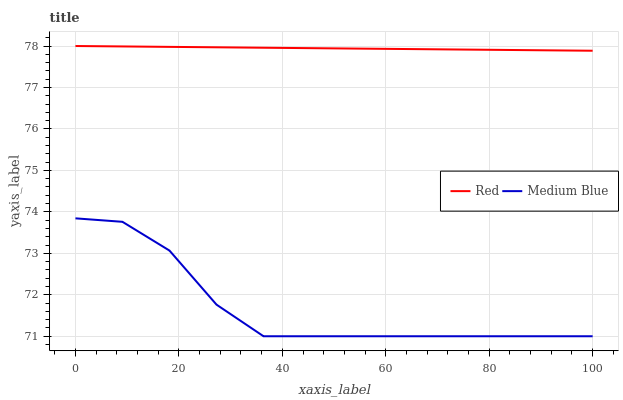Does Medium Blue have the minimum area under the curve?
Answer yes or no. Yes. Does Red have the maximum area under the curve?
Answer yes or no. Yes. Does Red have the minimum area under the curve?
Answer yes or no. No. Is Red the smoothest?
Answer yes or no. Yes. Is Medium Blue the roughest?
Answer yes or no. Yes. Is Red the roughest?
Answer yes or no. No. Does Medium Blue have the lowest value?
Answer yes or no. Yes. Does Red have the lowest value?
Answer yes or no. No. Does Red have the highest value?
Answer yes or no. Yes. Is Medium Blue less than Red?
Answer yes or no. Yes. Is Red greater than Medium Blue?
Answer yes or no. Yes. Does Medium Blue intersect Red?
Answer yes or no. No. 